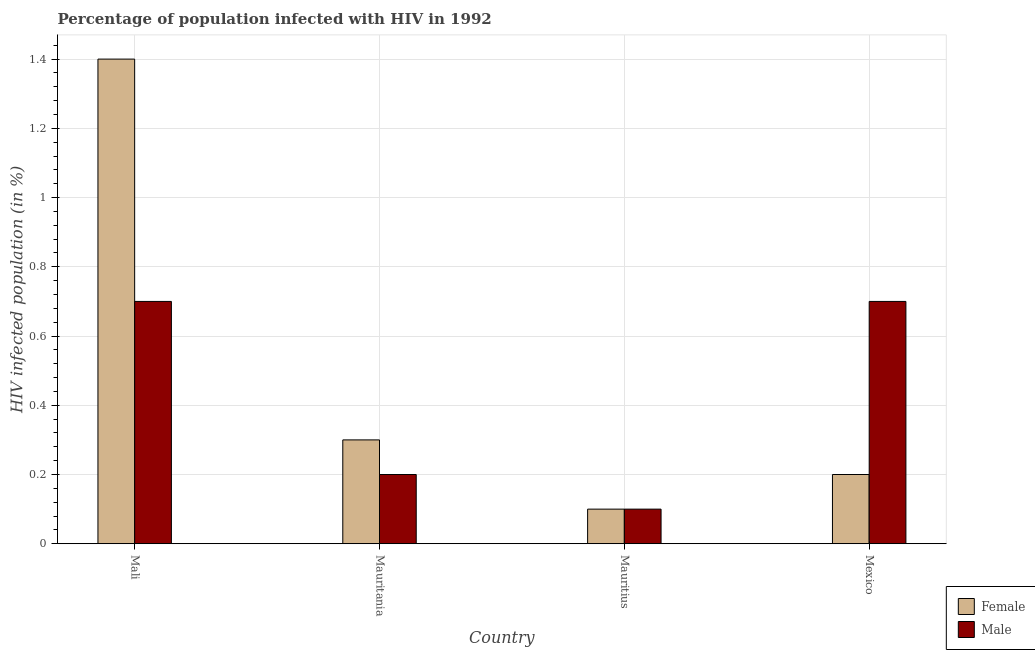Are the number of bars per tick equal to the number of legend labels?
Give a very brief answer. Yes. Are the number of bars on each tick of the X-axis equal?
Provide a short and direct response. Yes. What is the label of the 3rd group of bars from the left?
Provide a succinct answer. Mauritius. Across all countries, what is the maximum percentage of males who are infected with hiv?
Offer a very short reply. 0.7. In which country was the percentage of males who are infected with hiv maximum?
Provide a short and direct response. Mali. In which country was the percentage of males who are infected with hiv minimum?
Make the answer very short. Mauritius. What is the total percentage of females who are infected with hiv in the graph?
Keep it short and to the point. 2. What is the difference between the percentage of females who are infected with hiv in Mali and that in Mauritania?
Make the answer very short. 1.1. What is the difference between the percentage of males who are infected with hiv in Mexico and the percentage of females who are infected with hiv in Mauritania?
Offer a terse response. 0.4. What is the average percentage of females who are infected with hiv per country?
Give a very brief answer. 0.5. What is the difference between the percentage of males who are infected with hiv and percentage of females who are infected with hiv in Mauritius?
Keep it short and to the point. 0. In how many countries, is the percentage of females who are infected with hiv greater than 1 %?
Ensure brevity in your answer.  1. What is the ratio of the percentage of females who are infected with hiv in Mauritania to that in Mauritius?
Provide a short and direct response. 3. Is the percentage of females who are infected with hiv in Mali less than that in Mauritius?
Your answer should be very brief. No. What is the difference between the highest and the lowest percentage of females who are infected with hiv?
Your answer should be very brief. 1.3. What does the 2nd bar from the left in Mexico represents?
Your response must be concise. Male. What does the 2nd bar from the right in Mauritius represents?
Ensure brevity in your answer.  Female. How many countries are there in the graph?
Provide a succinct answer. 4. What is the difference between two consecutive major ticks on the Y-axis?
Offer a terse response. 0.2. Does the graph contain grids?
Keep it short and to the point. Yes. Where does the legend appear in the graph?
Provide a succinct answer. Bottom right. How are the legend labels stacked?
Ensure brevity in your answer.  Vertical. What is the title of the graph?
Offer a terse response. Percentage of population infected with HIV in 1992. Does "Girls" appear as one of the legend labels in the graph?
Your answer should be compact. No. What is the label or title of the Y-axis?
Provide a succinct answer. HIV infected population (in %). What is the HIV infected population (in %) in Male in Mali?
Your answer should be very brief. 0.7. What is the HIV infected population (in %) in Female in Mauritania?
Your answer should be very brief. 0.3. What is the HIV infected population (in %) of Male in Mauritania?
Offer a very short reply. 0.2. What is the HIV infected population (in %) of Female in Mauritius?
Keep it short and to the point. 0.1. What is the HIV infected population (in %) in Female in Mexico?
Your response must be concise. 0.2. What is the HIV infected population (in %) in Male in Mexico?
Provide a short and direct response. 0.7. Across all countries, what is the maximum HIV infected population (in %) of Male?
Your answer should be compact. 0.7. Across all countries, what is the minimum HIV infected population (in %) of Female?
Make the answer very short. 0.1. Across all countries, what is the minimum HIV infected population (in %) in Male?
Provide a succinct answer. 0.1. What is the difference between the HIV infected population (in %) of Female in Mali and that in Mauritius?
Keep it short and to the point. 1.3. What is the difference between the HIV infected population (in %) of Male in Mali and that in Mauritius?
Offer a very short reply. 0.6. What is the difference between the HIV infected population (in %) of Female in Mauritania and that in Mauritius?
Your answer should be compact. 0.2. What is the difference between the HIV infected population (in %) in Male in Mauritania and that in Mauritius?
Make the answer very short. 0.1. What is the difference between the HIV infected population (in %) in Female in Mauritania and that in Mexico?
Your response must be concise. 0.1. What is the difference between the HIV infected population (in %) in Male in Mauritania and that in Mexico?
Give a very brief answer. -0.5. What is the difference between the HIV infected population (in %) of Female in Mali and the HIV infected population (in %) of Male in Mauritania?
Keep it short and to the point. 1.2. What is the difference between the HIV infected population (in %) in Female in Mali and the HIV infected population (in %) in Male in Mexico?
Offer a terse response. 0.7. What is the difference between the HIV infected population (in %) in Female in Mauritius and the HIV infected population (in %) in Male in Mexico?
Make the answer very short. -0.6. What is the average HIV infected population (in %) of Female per country?
Your answer should be very brief. 0.5. What is the average HIV infected population (in %) in Male per country?
Offer a very short reply. 0.42. What is the difference between the HIV infected population (in %) of Female and HIV infected population (in %) of Male in Mali?
Offer a terse response. 0.7. What is the difference between the HIV infected population (in %) in Female and HIV infected population (in %) in Male in Mexico?
Offer a terse response. -0.5. What is the ratio of the HIV infected population (in %) in Female in Mali to that in Mauritania?
Give a very brief answer. 4.67. What is the ratio of the HIV infected population (in %) of Male in Mali to that in Mauritius?
Give a very brief answer. 7. What is the ratio of the HIV infected population (in %) in Male in Mali to that in Mexico?
Your answer should be very brief. 1. What is the ratio of the HIV infected population (in %) of Female in Mauritania to that in Mauritius?
Your answer should be very brief. 3. What is the ratio of the HIV infected population (in %) in Male in Mauritania to that in Mexico?
Your answer should be very brief. 0.29. What is the ratio of the HIV infected population (in %) in Male in Mauritius to that in Mexico?
Your answer should be very brief. 0.14. What is the difference between the highest and the second highest HIV infected population (in %) in Male?
Ensure brevity in your answer.  0. 